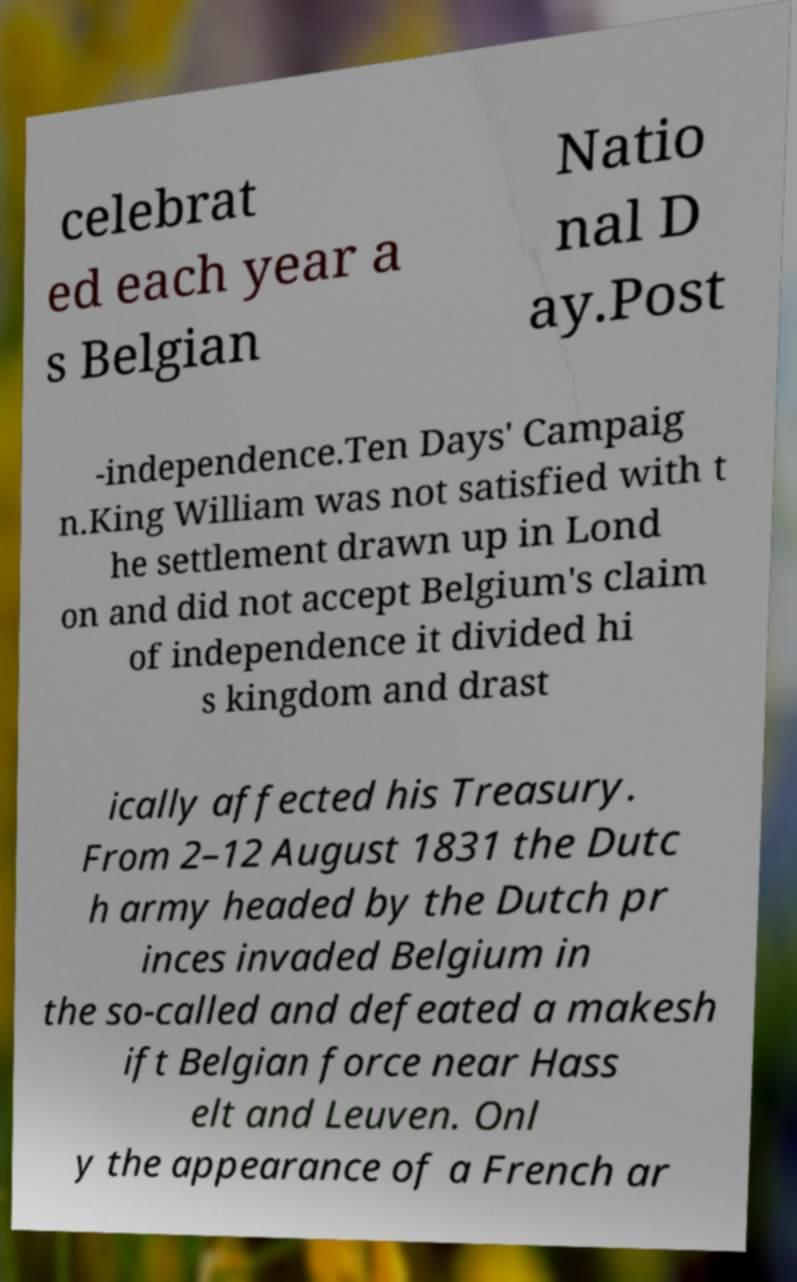Can you read and provide the text displayed in the image?This photo seems to have some interesting text. Can you extract and type it out for me? celebrat ed each year a s Belgian Natio nal D ay.Post -independence.Ten Days' Campaig n.King William was not satisfied with t he settlement drawn up in Lond on and did not accept Belgium's claim of independence it divided hi s kingdom and drast ically affected his Treasury. From 2–12 August 1831 the Dutc h army headed by the Dutch pr inces invaded Belgium in the so-called and defeated a makesh ift Belgian force near Hass elt and Leuven. Onl y the appearance of a French ar 